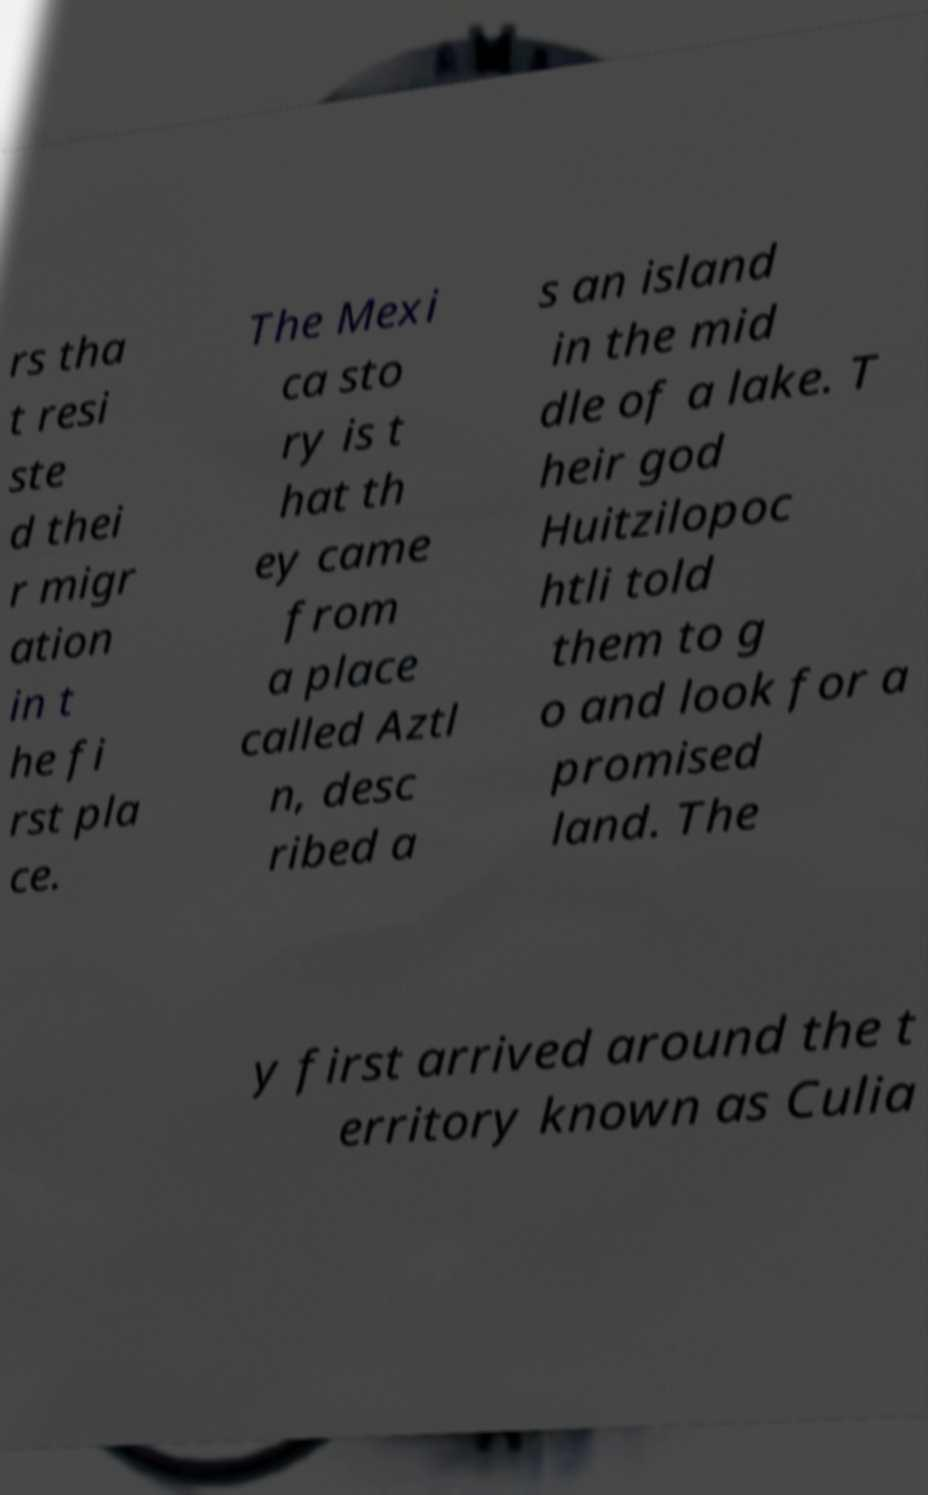For documentation purposes, I need the text within this image transcribed. Could you provide that? rs tha t resi ste d thei r migr ation in t he fi rst pla ce. The Mexi ca sto ry is t hat th ey came from a place called Aztl n, desc ribed a s an island in the mid dle of a lake. T heir god Huitzilopoc htli told them to g o and look for a promised land. The y first arrived around the t erritory known as Culia 